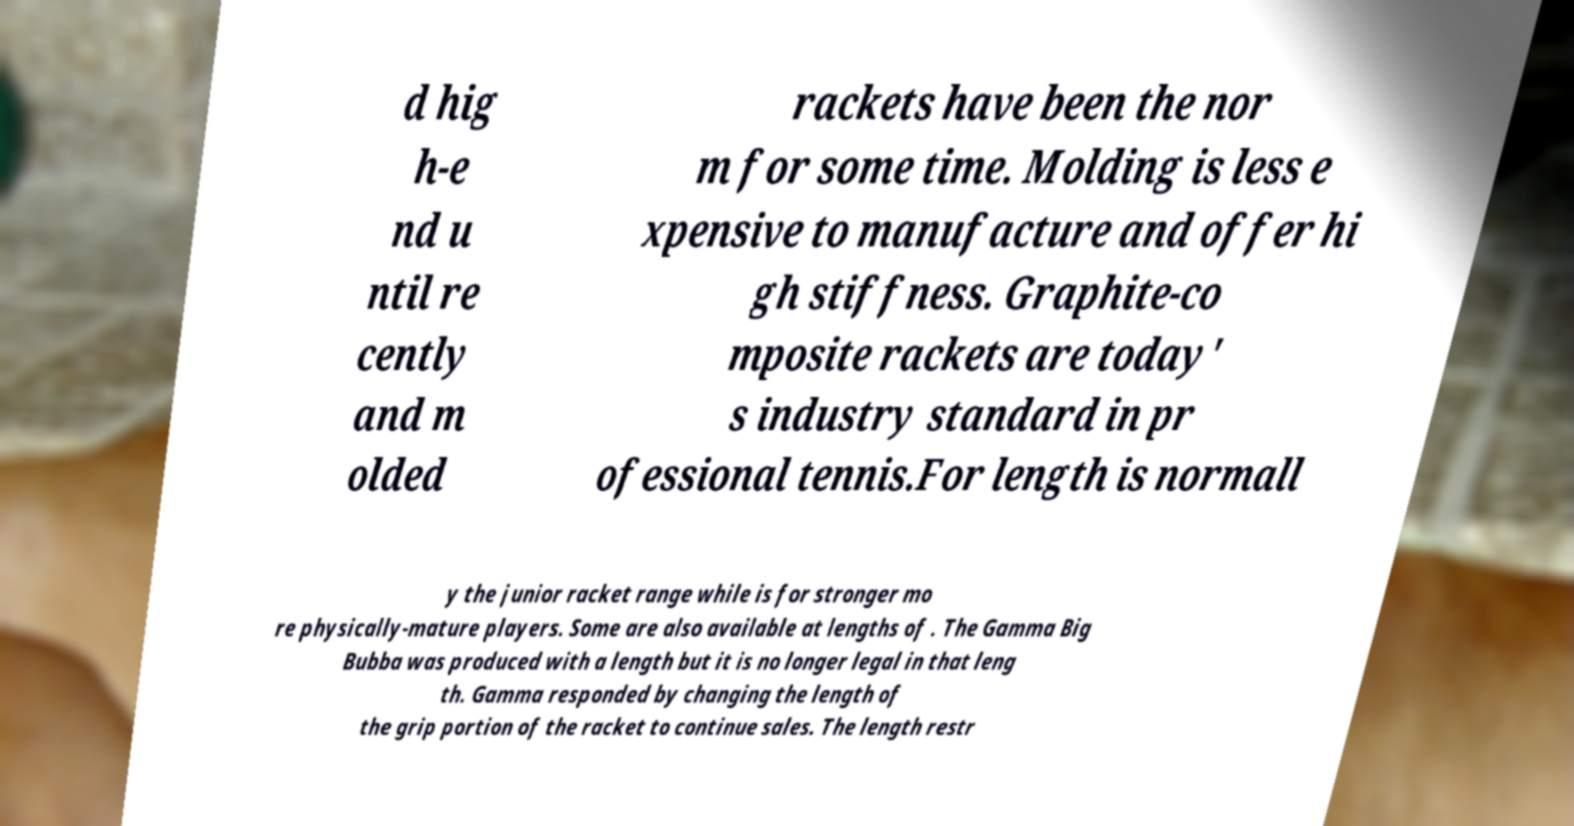Could you assist in decoding the text presented in this image and type it out clearly? d hig h-e nd u ntil re cently and m olded rackets have been the nor m for some time. Molding is less e xpensive to manufacture and offer hi gh stiffness. Graphite-co mposite rackets are today' s industry standard in pr ofessional tennis.For length is normall y the junior racket range while is for stronger mo re physically-mature players. Some are also available at lengths of . The Gamma Big Bubba was produced with a length but it is no longer legal in that leng th. Gamma responded by changing the length of the grip portion of the racket to continue sales. The length restr 